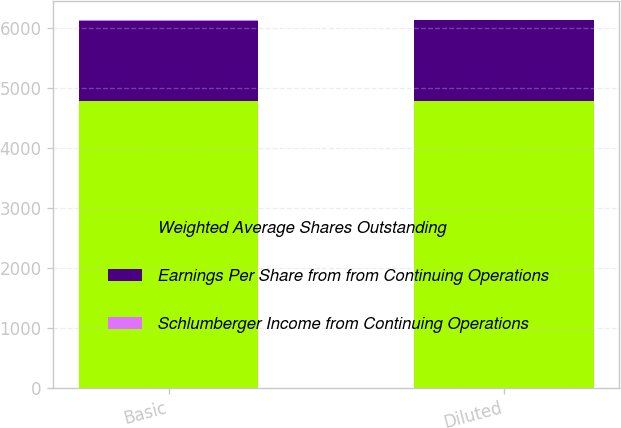<chart> <loc_0><loc_0><loc_500><loc_500><stacked_bar_chart><ecel><fcel>Basic<fcel>Diluted<nl><fcel>Weighted Average Shares Outstanding<fcel>4777<fcel>4777<nl><fcel>Earnings Per Share from from Continuing Operations<fcel>1349<fcel>1361<nl><fcel>Schlumberger Income from Continuing Operations<fcel>3.54<fcel>3.51<nl></chart> 